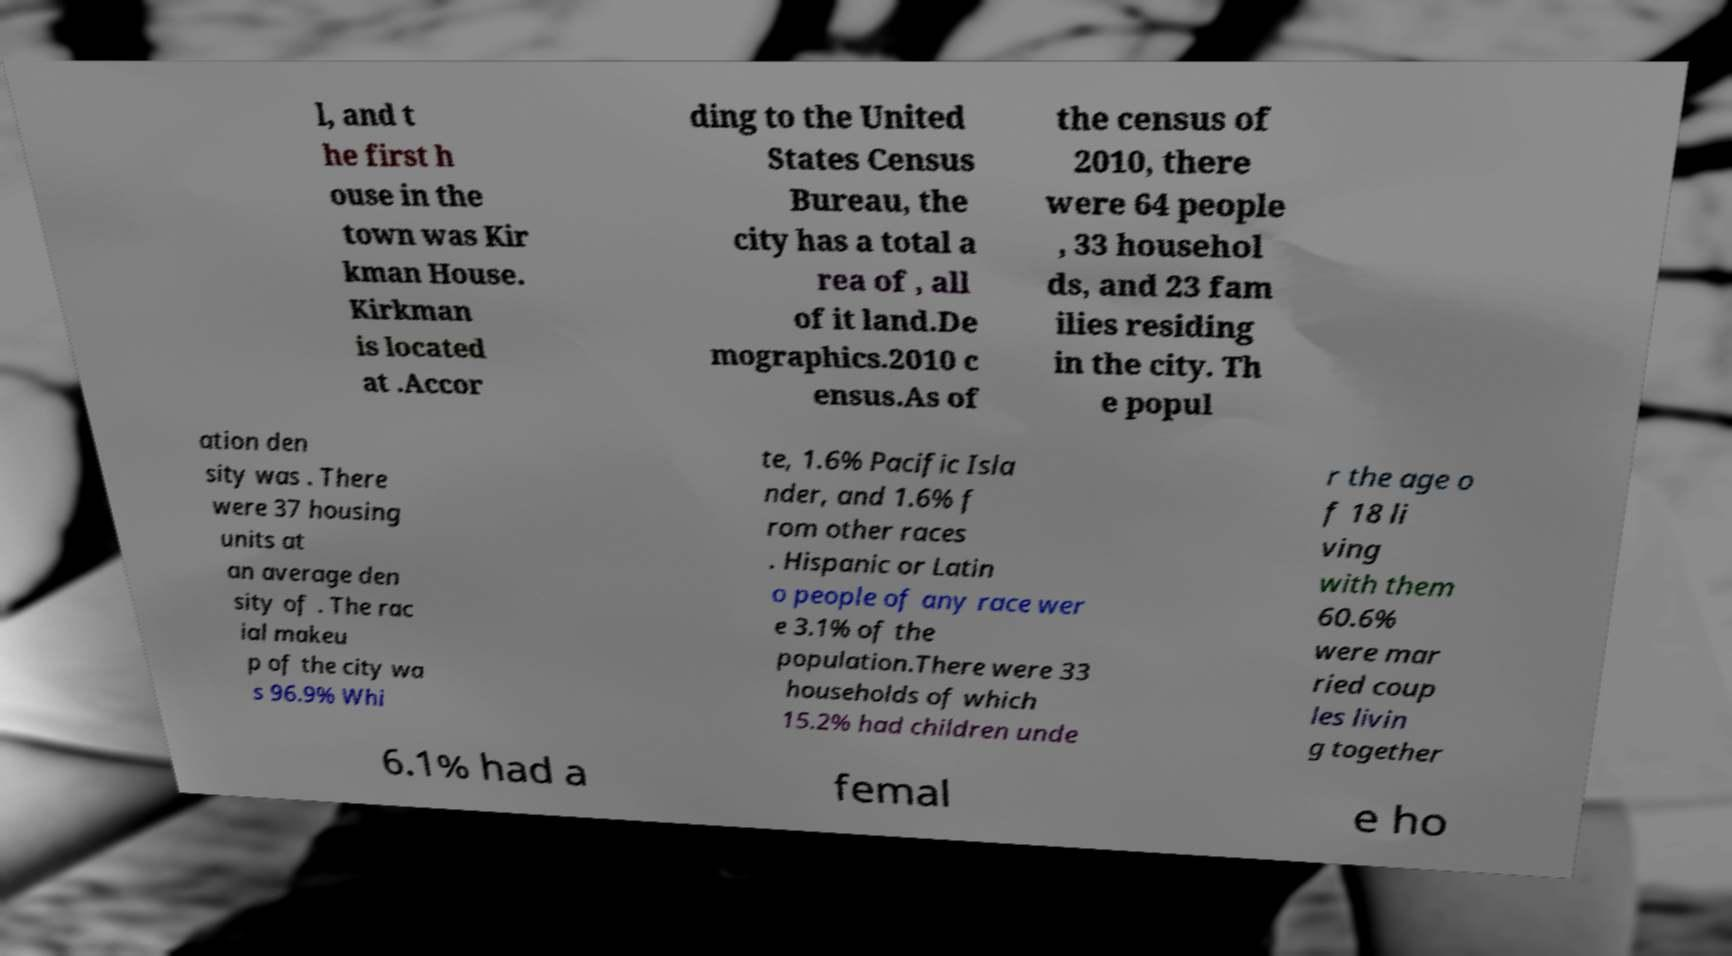Could you extract and type out the text from this image? l, and t he first h ouse in the town was Kir kman House. Kirkman is located at .Accor ding to the United States Census Bureau, the city has a total a rea of , all of it land.De mographics.2010 c ensus.As of the census of 2010, there were 64 people , 33 househol ds, and 23 fam ilies residing in the city. Th e popul ation den sity was . There were 37 housing units at an average den sity of . The rac ial makeu p of the city wa s 96.9% Whi te, 1.6% Pacific Isla nder, and 1.6% f rom other races . Hispanic or Latin o people of any race wer e 3.1% of the population.There were 33 households of which 15.2% had children unde r the age o f 18 li ving with them 60.6% were mar ried coup les livin g together 6.1% had a femal e ho 